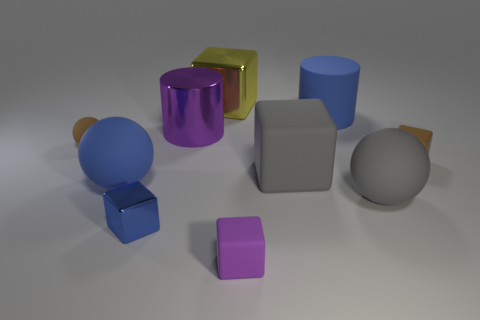Subtract all brown cubes. How many cubes are left? 4 Subtract all big gray blocks. How many blocks are left? 4 Subtract all green cubes. Subtract all green cylinders. How many cubes are left? 5 Subtract all cylinders. How many objects are left? 8 Subtract all purple rubber things. Subtract all blue rubber objects. How many objects are left? 7 Add 5 large cubes. How many large cubes are left? 7 Add 2 large brown shiny cylinders. How many large brown shiny cylinders exist? 2 Subtract 1 blue balls. How many objects are left? 9 